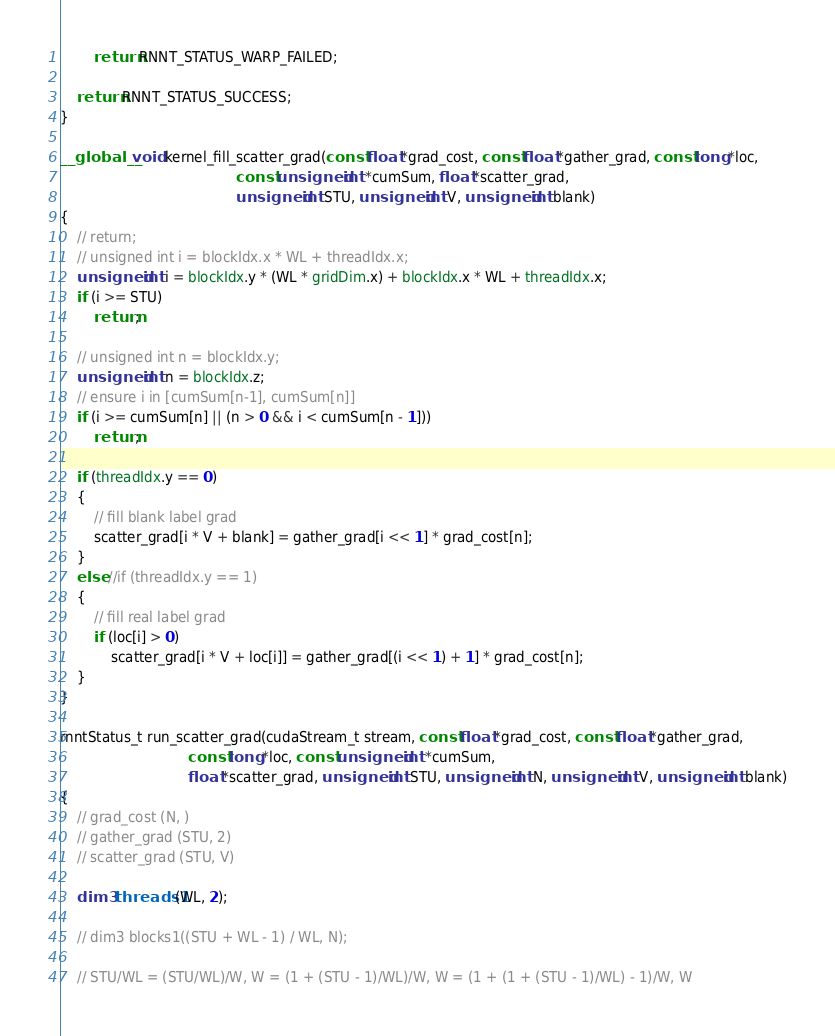Convert code to text. <code><loc_0><loc_0><loc_500><loc_500><_Cuda_>        return RNNT_STATUS_WARP_FAILED;

    return RNNT_STATUS_SUCCESS;
}

__global__ void kernel_fill_scatter_grad(const float *grad_cost, const float *gather_grad, const long *loc,
                                         const unsigned int *cumSum, float *scatter_grad,
                                         unsigned int STU, unsigned int V, unsigned int blank)
{
    // return;
    // unsigned int i = blockIdx.x * WL + threadIdx.x;
    unsigned int i = blockIdx.y * (WL * gridDim.x) + blockIdx.x * WL + threadIdx.x;
    if (i >= STU)
        return;

    // unsigned int n = blockIdx.y;
    unsigned int n = blockIdx.z;
    // ensure i in [cumSum[n-1], cumSum[n]]
    if (i >= cumSum[n] || (n > 0 && i < cumSum[n - 1]))
        return;

    if (threadIdx.y == 0)
    {
        // fill blank label grad
        scatter_grad[i * V + blank] = gather_grad[i << 1] * grad_cost[n];
    }
    else //if (threadIdx.y == 1)
    {
        // fill real label grad
        if (loc[i] > 0)
            scatter_grad[i * V + loc[i]] = gather_grad[(i << 1) + 1] * grad_cost[n];
    }
}

rnntStatus_t run_scatter_grad(cudaStream_t stream, const float *grad_cost, const float *gather_grad,
                              const long *loc, const unsigned int *cumSum,
                              float *scatter_grad, unsigned int STU, unsigned int N, unsigned int V, unsigned int blank)
{
    // grad_cost (N, )
    // gather_grad (STU, 2)
    // scatter_grad (STU, V)

    dim3 threads1(WL, 2);

    // dim3 blocks1((STU + WL - 1) / WL, N);

    // STU/WL = (STU/WL)/W, W = (1 + (STU - 1)/WL)/W, W = (1 + (1 + (STU - 1)/WL) - 1)/W, W</code> 